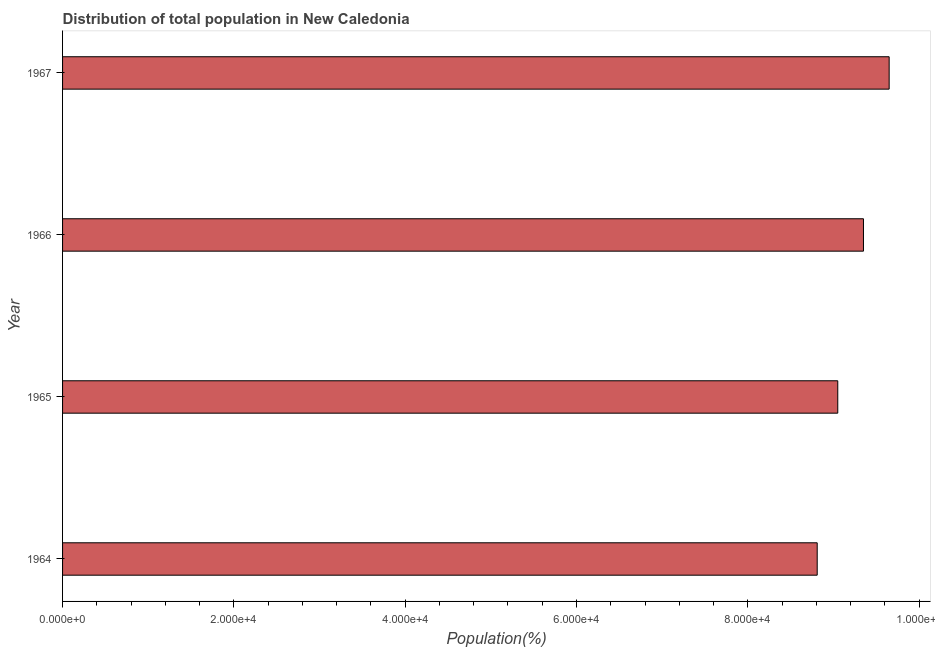Does the graph contain any zero values?
Give a very brief answer. No. Does the graph contain grids?
Your answer should be very brief. No. What is the title of the graph?
Offer a very short reply. Distribution of total population in New Caledonia . What is the label or title of the X-axis?
Give a very brief answer. Population(%). What is the label or title of the Y-axis?
Provide a succinct answer. Year. What is the population in 1965?
Keep it short and to the point. 9.05e+04. Across all years, what is the maximum population?
Provide a short and direct response. 9.65e+04. Across all years, what is the minimum population?
Your answer should be very brief. 8.81e+04. In which year was the population maximum?
Keep it short and to the point. 1967. In which year was the population minimum?
Keep it short and to the point. 1964. What is the sum of the population?
Offer a very short reply. 3.69e+05. What is the difference between the population in 1965 and 1967?
Provide a short and direct response. -6000. What is the average population per year?
Your response must be concise. 9.22e+04. What is the median population?
Make the answer very short. 9.20e+04. Do a majority of the years between 1965 and 1967 (inclusive) have population greater than 80000 %?
Ensure brevity in your answer.  Yes. Is the difference between the population in 1964 and 1965 greater than the difference between any two years?
Ensure brevity in your answer.  No. What is the difference between the highest and the second highest population?
Provide a succinct answer. 3000. Is the sum of the population in 1966 and 1967 greater than the maximum population across all years?
Make the answer very short. Yes. What is the difference between the highest and the lowest population?
Provide a succinct answer. 8400. In how many years, is the population greater than the average population taken over all years?
Your answer should be very brief. 2. How many bars are there?
Offer a terse response. 4. Are the values on the major ticks of X-axis written in scientific E-notation?
Offer a terse response. Yes. What is the Population(%) in 1964?
Give a very brief answer. 8.81e+04. What is the Population(%) of 1965?
Keep it short and to the point. 9.05e+04. What is the Population(%) in 1966?
Your answer should be compact. 9.35e+04. What is the Population(%) in 1967?
Provide a short and direct response. 9.65e+04. What is the difference between the Population(%) in 1964 and 1965?
Your answer should be compact. -2400. What is the difference between the Population(%) in 1964 and 1966?
Offer a terse response. -5400. What is the difference between the Population(%) in 1964 and 1967?
Keep it short and to the point. -8400. What is the difference between the Population(%) in 1965 and 1966?
Your answer should be compact. -3000. What is the difference between the Population(%) in 1965 and 1967?
Keep it short and to the point. -6000. What is the difference between the Population(%) in 1966 and 1967?
Your response must be concise. -3000. What is the ratio of the Population(%) in 1964 to that in 1965?
Your response must be concise. 0.97. What is the ratio of the Population(%) in 1964 to that in 1966?
Offer a very short reply. 0.94. What is the ratio of the Population(%) in 1964 to that in 1967?
Your response must be concise. 0.91. What is the ratio of the Population(%) in 1965 to that in 1966?
Your answer should be compact. 0.97. What is the ratio of the Population(%) in 1965 to that in 1967?
Provide a short and direct response. 0.94. 